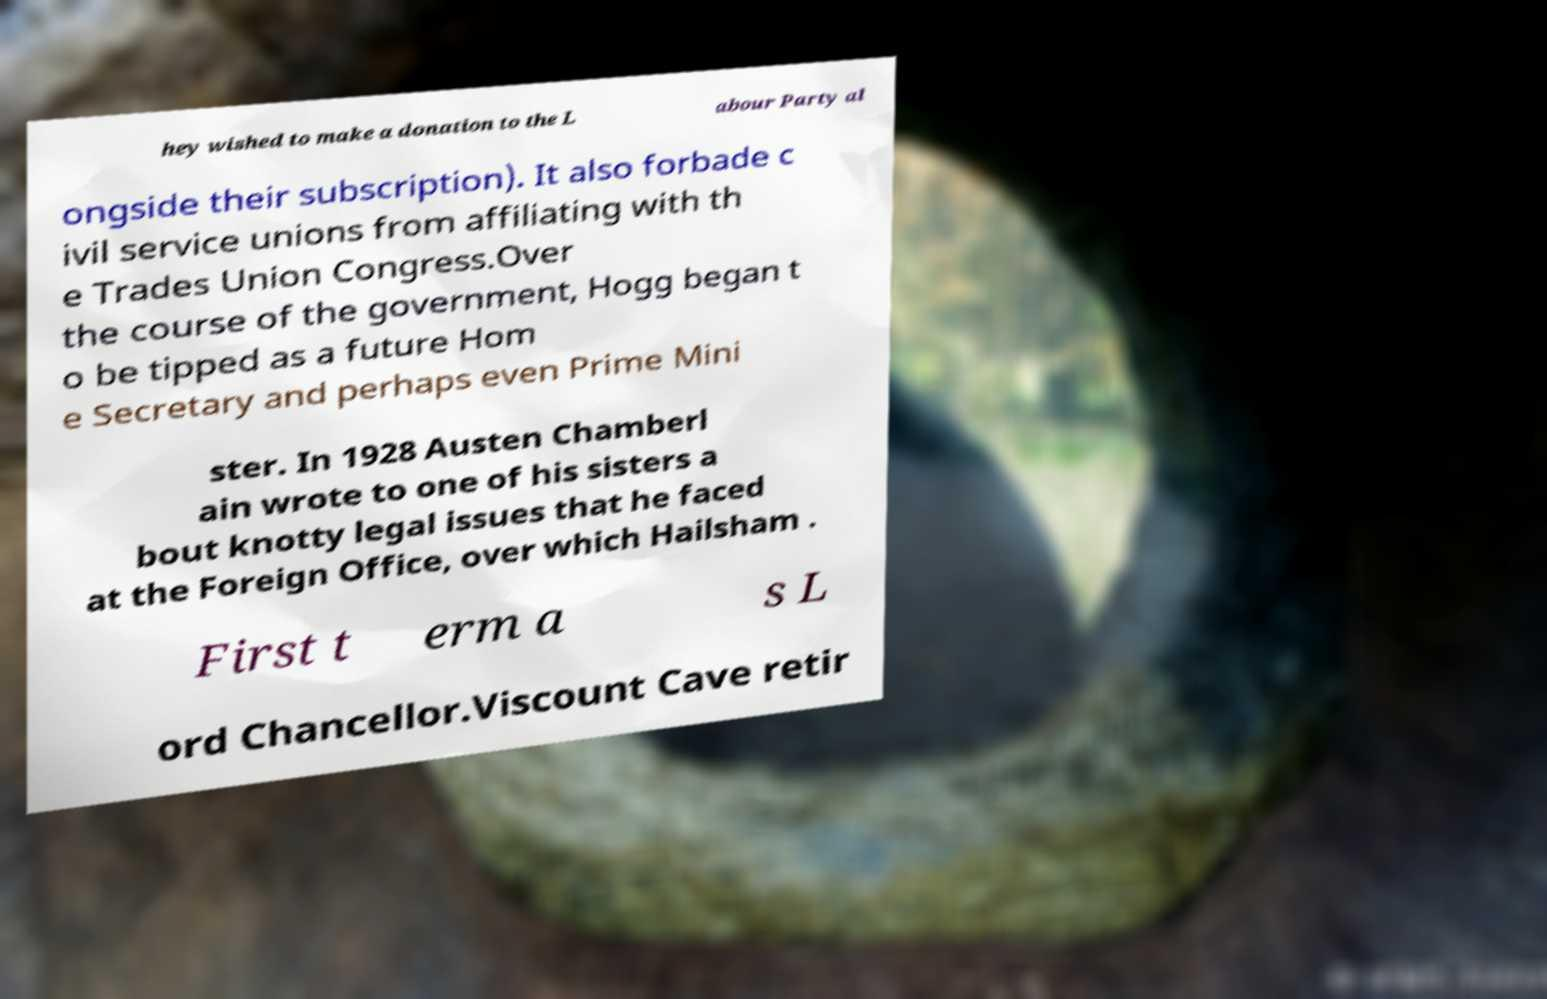Can you read and provide the text displayed in the image?This photo seems to have some interesting text. Can you extract and type it out for me? hey wished to make a donation to the L abour Party al ongside their subscription). It also forbade c ivil service unions from affiliating with th e Trades Union Congress.Over the course of the government, Hogg began t o be tipped as a future Hom e Secretary and perhaps even Prime Mini ster. In 1928 Austen Chamberl ain wrote to one of his sisters a bout knotty legal issues that he faced at the Foreign Office, over which Hailsham . First t erm a s L ord Chancellor.Viscount Cave retir 